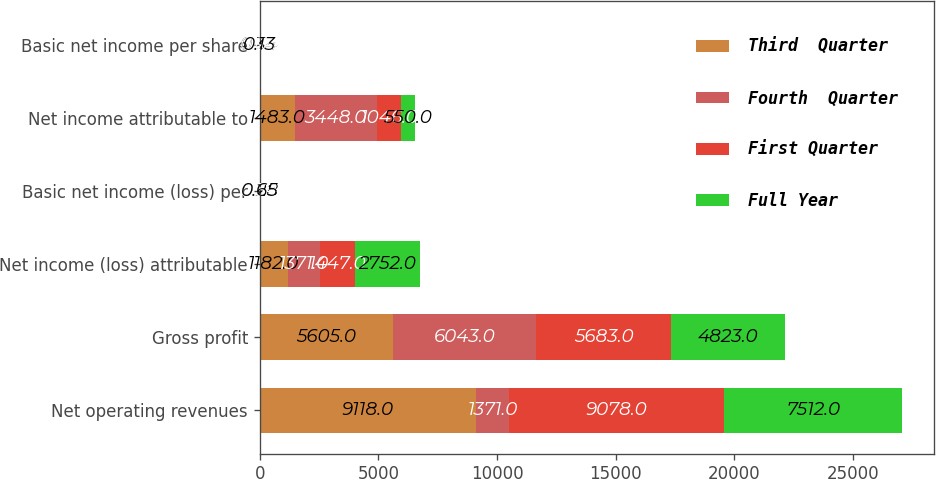<chart> <loc_0><loc_0><loc_500><loc_500><stacked_bar_chart><ecel><fcel>Net operating revenues<fcel>Gross profit<fcel>Net income (loss) attributable<fcel>Basic net income (loss) per<fcel>Net income attributable to<fcel>Basic net income per share<nl><fcel>Third  Quarter<fcel>9118<fcel>5605<fcel>1182<fcel>0.28<fcel>1483<fcel>0.34<nl><fcel>Fourth  Quarter<fcel>1371<fcel>6043<fcel>1371<fcel>0.32<fcel>3448<fcel>0.8<nl><fcel>First Quarter<fcel>9078<fcel>5683<fcel>1447<fcel>0.34<fcel>1046<fcel>0.24<nl><fcel>Full Year<fcel>7512<fcel>4823<fcel>2752<fcel>0.65<fcel>550<fcel>0.13<nl></chart> 